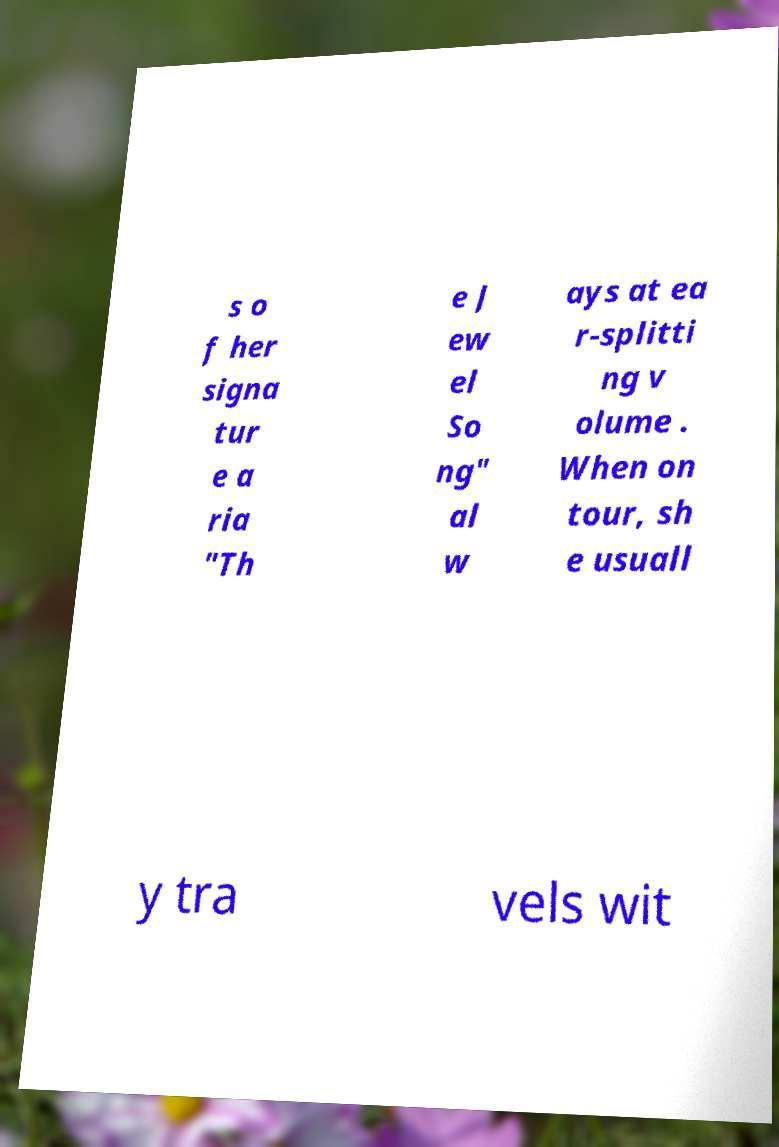Can you read and provide the text displayed in the image?This photo seems to have some interesting text. Can you extract and type it out for me? s o f her signa tur e a ria "Th e J ew el So ng" al w ays at ea r-splitti ng v olume . When on tour, sh e usuall y tra vels wit 